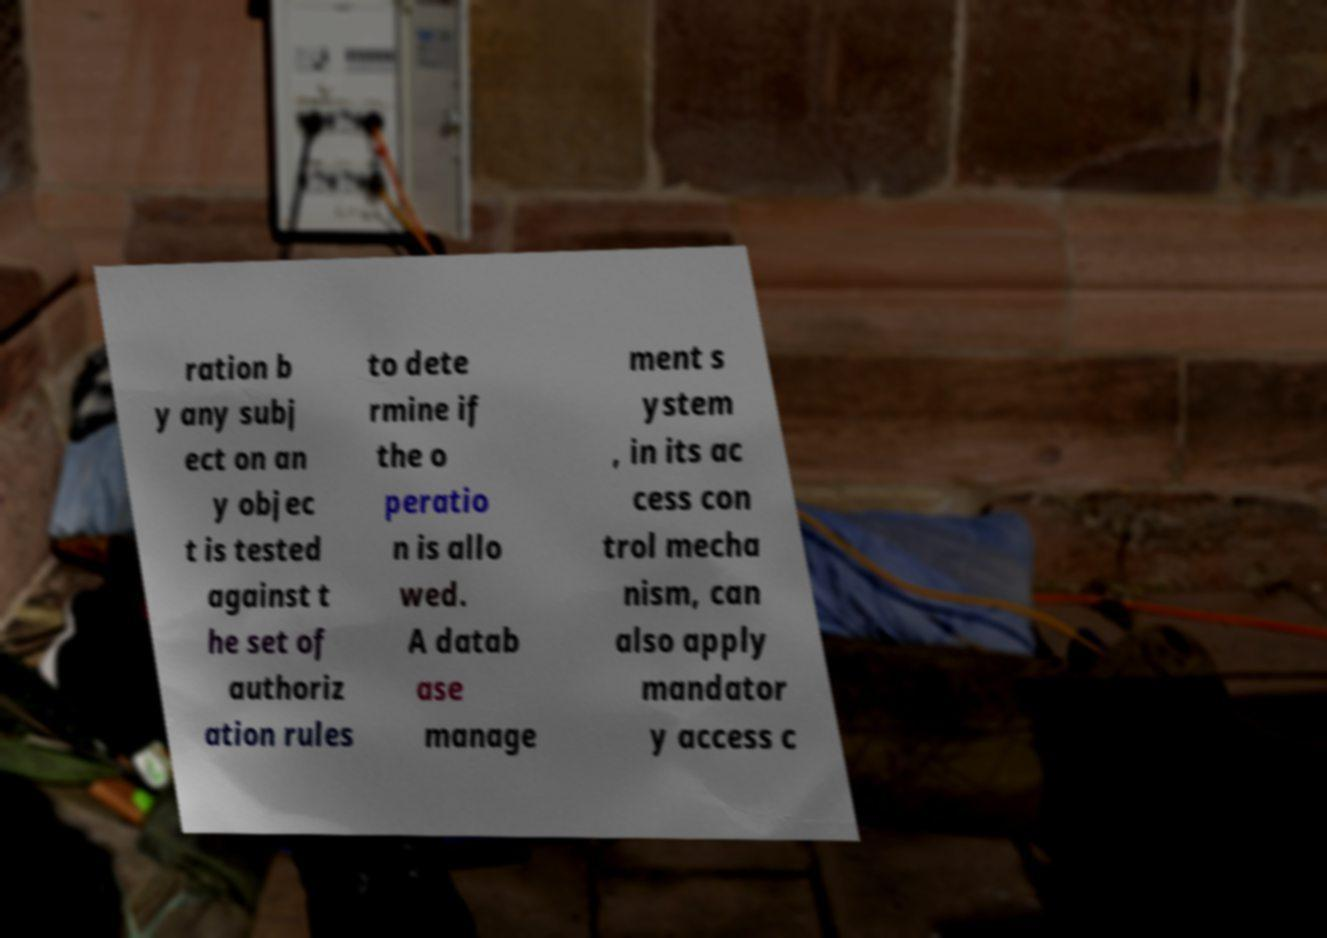Can you read and provide the text displayed in the image?This photo seems to have some interesting text. Can you extract and type it out for me? ration b y any subj ect on an y objec t is tested against t he set of authoriz ation rules to dete rmine if the o peratio n is allo wed. A datab ase manage ment s ystem , in its ac cess con trol mecha nism, can also apply mandator y access c 